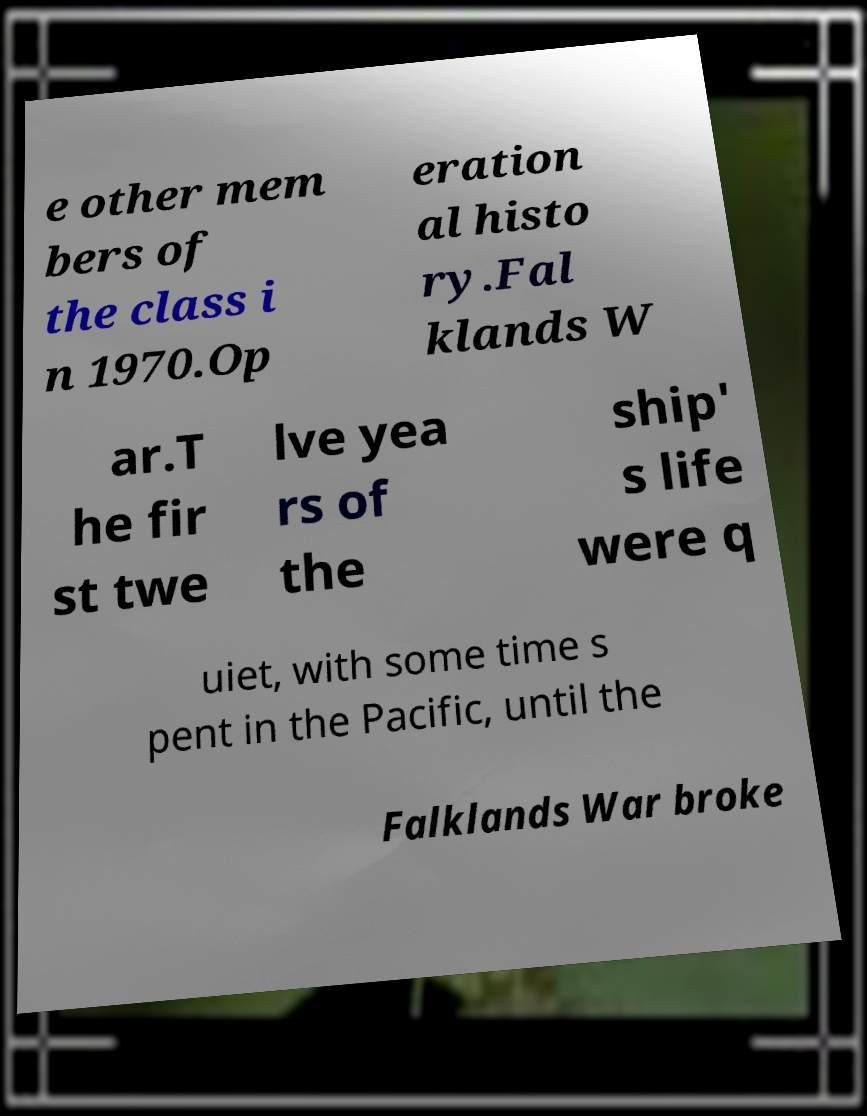For documentation purposes, I need the text within this image transcribed. Could you provide that? e other mem bers of the class i n 1970.Op eration al histo ry.Fal klands W ar.T he fir st twe lve yea rs of the ship' s life were q uiet, with some time s pent in the Pacific, until the Falklands War broke 